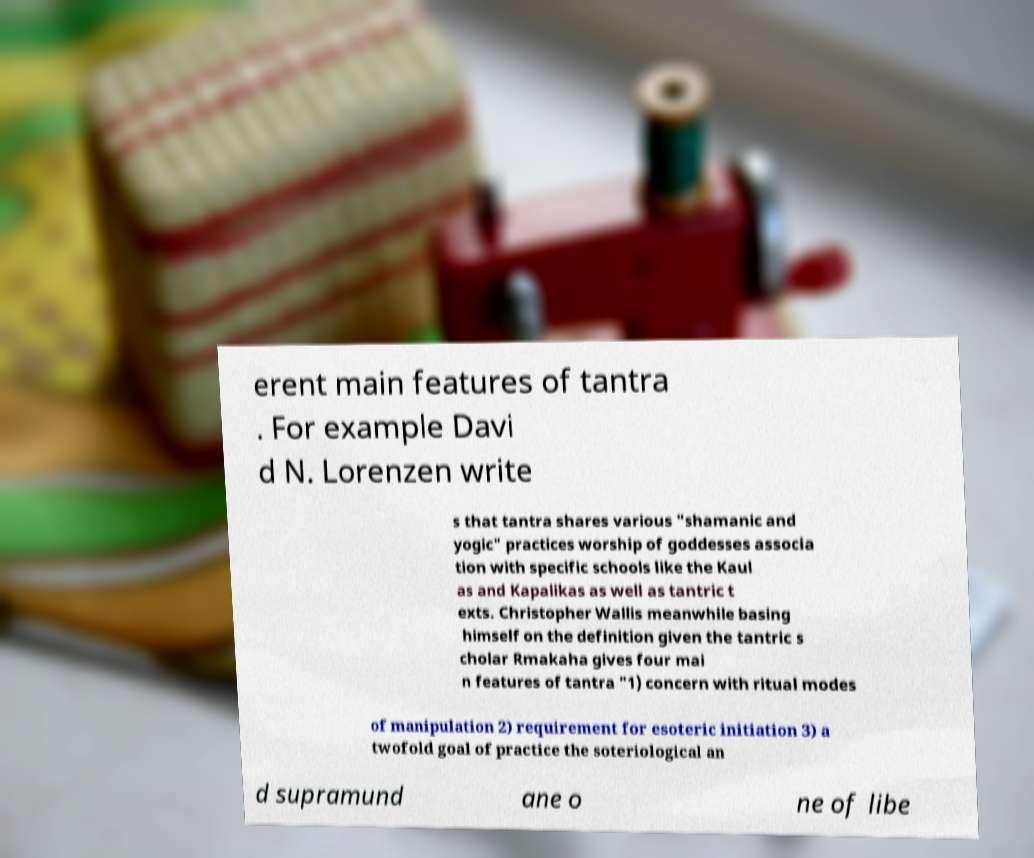Could you extract and type out the text from this image? erent main features of tantra . For example Davi d N. Lorenzen write s that tantra shares various "shamanic and yogic" practices worship of goddesses associa tion with specific schools like the Kaul as and Kapalikas as well as tantric t exts. Christopher Wallis meanwhile basing himself on the definition given the tantric s cholar Rmakaha gives four mai n features of tantra "1) concern with ritual modes of manipulation 2) requirement for esoteric initiation 3) a twofold goal of practice the soteriological an d supramund ane o ne of libe 